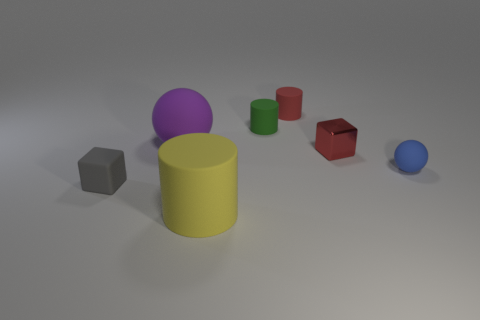Do the shadows cast by the objects suggest a light source direction? Yes, the shadows are cast towards the bottom right of the image, implying that the light source is located towards the top left, out of the frame.  Could you guess the time of day based on the lighting in this scene if it were outdoors? As the lighting in the image has a soft, diffused quality, it might suggest an overcast day. However, given this is a controlled indoor setting, inferring a specific time of day is not applicable. 